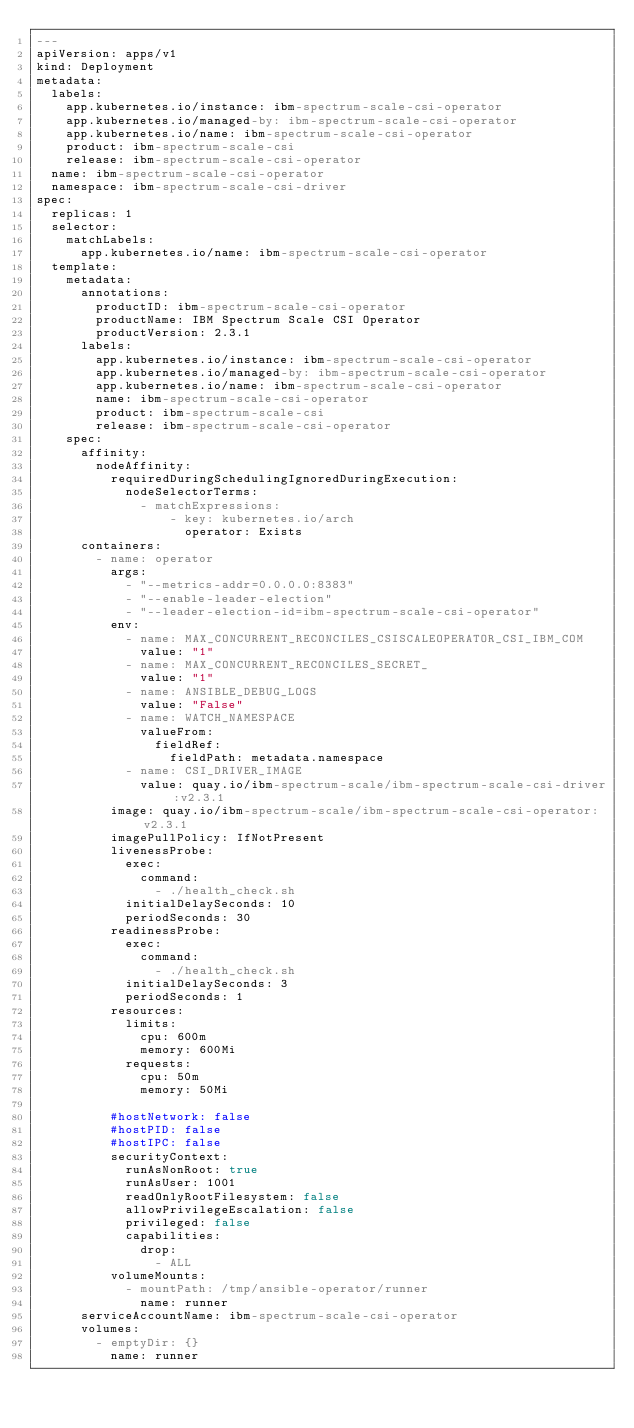<code> <loc_0><loc_0><loc_500><loc_500><_YAML_>---
apiVersion: apps/v1
kind: Deployment
metadata:
  labels:
    app.kubernetes.io/instance: ibm-spectrum-scale-csi-operator
    app.kubernetes.io/managed-by: ibm-spectrum-scale-csi-operator
    app.kubernetes.io/name: ibm-spectrum-scale-csi-operator
    product: ibm-spectrum-scale-csi
    release: ibm-spectrum-scale-csi-operator
  name: ibm-spectrum-scale-csi-operator
  namespace: ibm-spectrum-scale-csi-driver
spec:
  replicas: 1
  selector:
    matchLabels:
      app.kubernetes.io/name: ibm-spectrum-scale-csi-operator
  template:
    metadata:
      annotations:
        productID: ibm-spectrum-scale-csi-operator
        productName: IBM Spectrum Scale CSI Operator
        productVersion: 2.3.1
      labels:
        app.kubernetes.io/instance: ibm-spectrum-scale-csi-operator
        app.kubernetes.io/managed-by: ibm-spectrum-scale-csi-operator
        app.kubernetes.io/name: ibm-spectrum-scale-csi-operator
        name: ibm-spectrum-scale-csi-operator
        product: ibm-spectrum-scale-csi
        release: ibm-spectrum-scale-csi-operator
    spec:
      affinity:
        nodeAffinity:
          requiredDuringSchedulingIgnoredDuringExecution:
            nodeSelectorTerms:
              - matchExpressions:
                  - key: kubernetes.io/arch
                    operator: Exists
      containers:
        - name: operator
          args:
            - "--metrics-addr=0.0.0.0:8383"
            - "--enable-leader-election"
            - "--leader-election-id=ibm-spectrum-scale-csi-operator"
          env:
            - name: MAX_CONCURRENT_RECONCILES_CSISCALEOPERATOR_CSI_IBM_COM
              value: "1"
            - name: MAX_CONCURRENT_RECONCILES_SECRET_
              value: "1"
            - name: ANSIBLE_DEBUG_LOGS
              value: "False"
            - name: WATCH_NAMESPACE
              valueFrom:
                fieldRef:
                  fieldPath: metadata.namespace
            - name: CSI_DRIVER_IMAGE
              value: quay.io/ibm-spectrum-scale/ibm-spectrum-scale-csi-driver:v2.3.1
          image: quay.io/ibm-spectrum-scale/ibm-spectrum-scale-csi-operator:v2.3.1
          imagePullPolicy: IfNotPresent
          livenessProbe:
            exec:
              command:
                - ./health_check.sh
            initialDelaySeconds: 10
            periodSeconds: 30
          readinessProbe:
            exec:
              command:
                - ./health_check.sh
            initialDelaySeconds: 3
            periodSeconds: 1
          resources:
            limits:
              cpu: 600m
              memory: 600Mi
            requests:
              cpu: 50m
              memory: 50Mi

          #hostNetwork: false
          #hostPID: false
          #hostIPC: false
          securityContext:
            runAsNonRoot: true
            runAsUser: 1001
            readOnlyRootFilesystem: false
            allowPrivilegeEscalation: false
            privileged: false
            capabilities:
              drop:
                - ALL
          volumeMounts:
            - mountPath: /tmp/ansible-operator/runner
              name: runner
      serviceAccountName: ibm-spectrum-scale-csi-operator
      volumes:
        - emptyDir: {}
          name: runner
</code> 